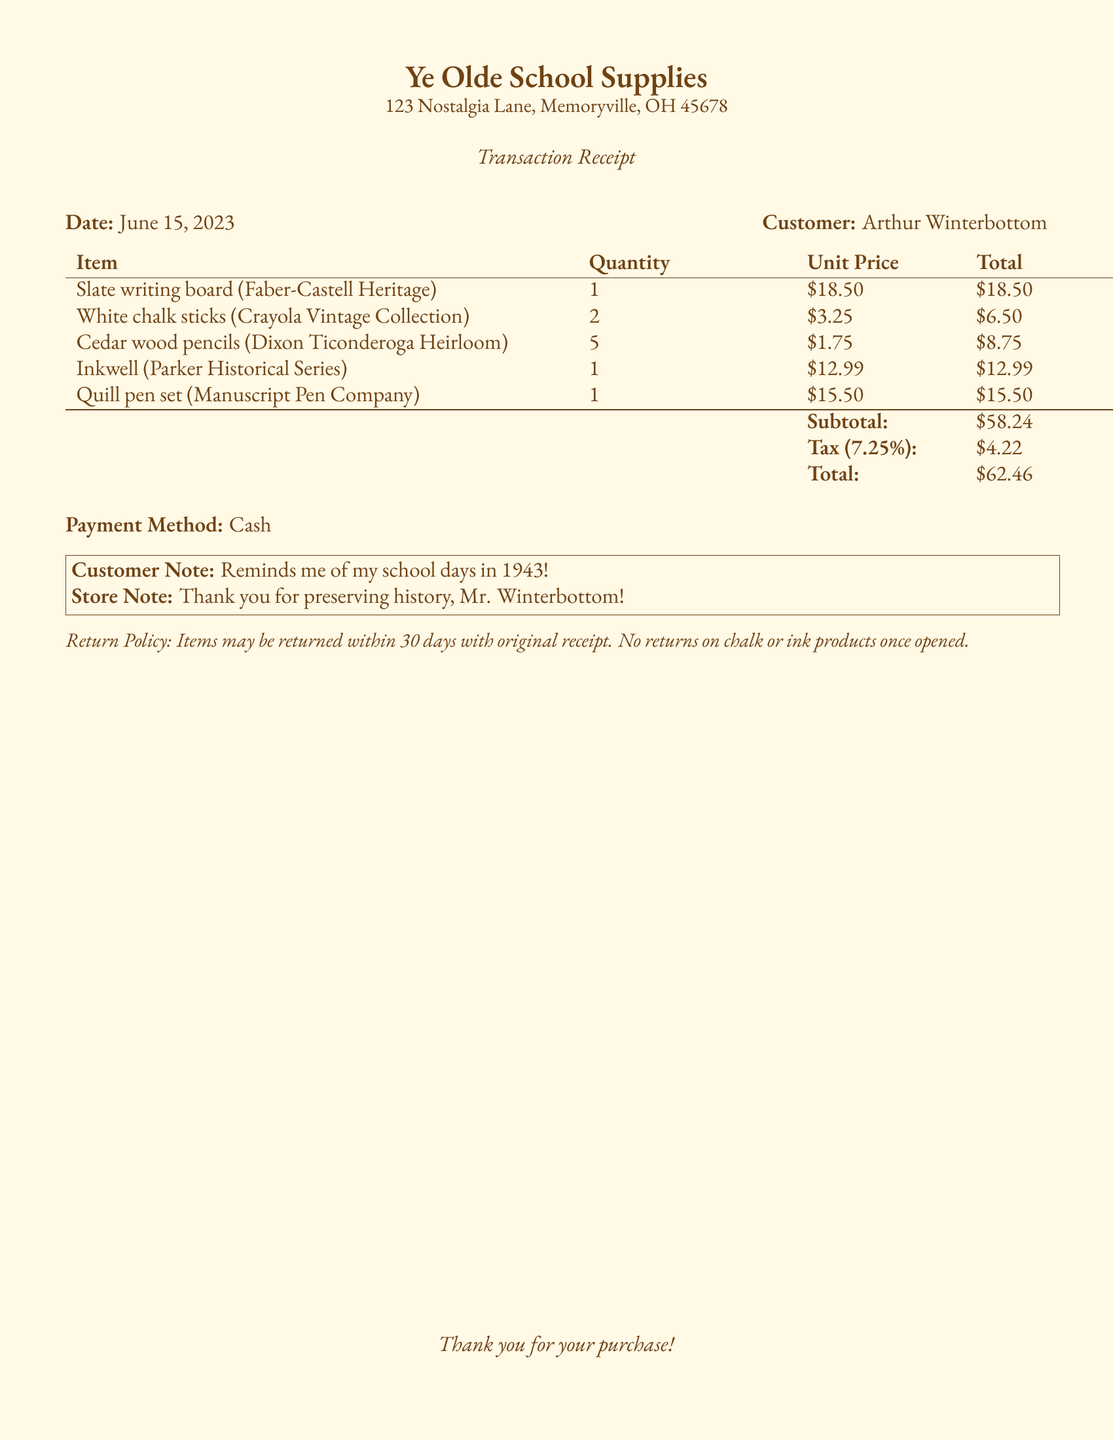What is the name of the store? The store name is clearly stated at the top of the document.
Answer: Ye Olde School Supplies What is the date of the transaction? The transaction date is listed in a dedicated section of the document.
Answer: June 15, 2023 Who is the customer? The customer's name is mentioned in connection with the transaction details.
Answer: Arthur Winterbottom What is the total amount of the purchase? The total amount is calculated at the end of the itemized list in the document.
Answer: $62.46 How many Cedar wood pencils were purchased? The quantity of Cedar wood pencils is specified in the item list.
Answer: 5 What is the tax rate applied to the purchase? The tax rate is indicated in the subtotal and tax calculations.
Answer: 7.25% What payment method was used? The payment method is mentioned in a specific section of the document.
Answer: Cash What note does the store provide to the customer? The store note is included in a highlighted box toward the bottom of the receipt.
Answer: Thank you for preserving history, Mr. Winterbottom! What is the return policy? The return policy is outlined at the bottom of the document.
Answer: Items may be returned within 30 days with original receipt. No returns on chalk or ink products once opened 